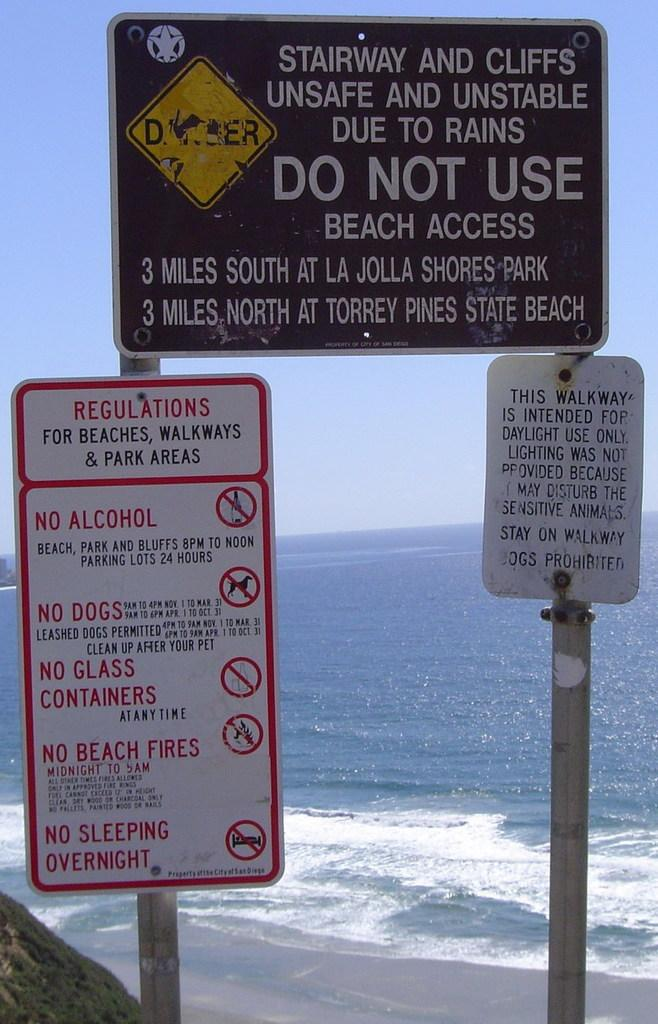<image>
Create a compact narrative representing the image presented. Three signs in front of the ocean, one of which warns of unsafe Stairway and cliffs. 